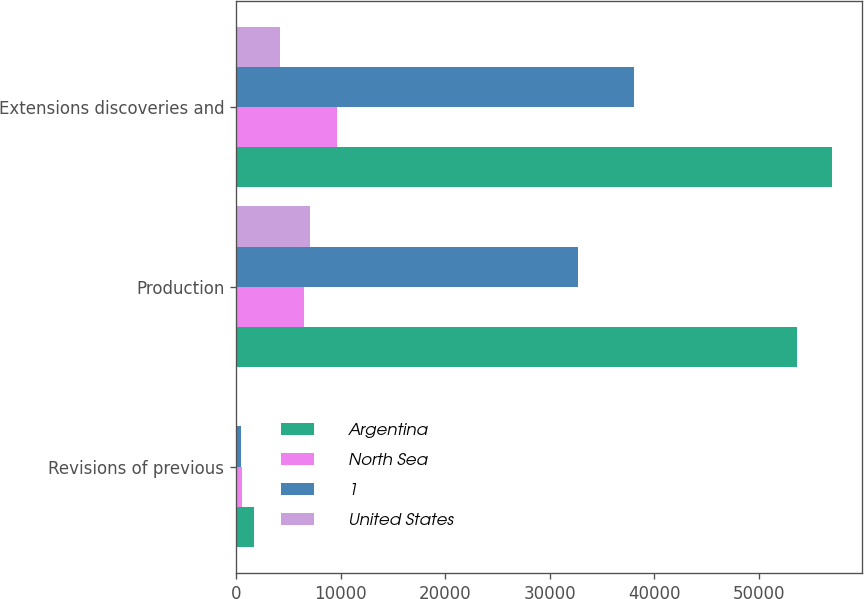<chart> <loc_0><loc_0><loc_500><loc_500><stacked_bar_chart><ecel><fcel>Revisions of previous<fcel>Production<fcel>Extensions discoveries and<nl><fcel>Argentina<fcel>1683<fcel>53621<fcel>57011<nl><fcel>North Sea<fcel>531<fcel>6469<fcel>9657<nl><fcel>1<fcel>457<fcel>32690<fcel>38074<nl><fcel>United States<fcel>118<fcel>7055<fcel>4254<nl></chart> 